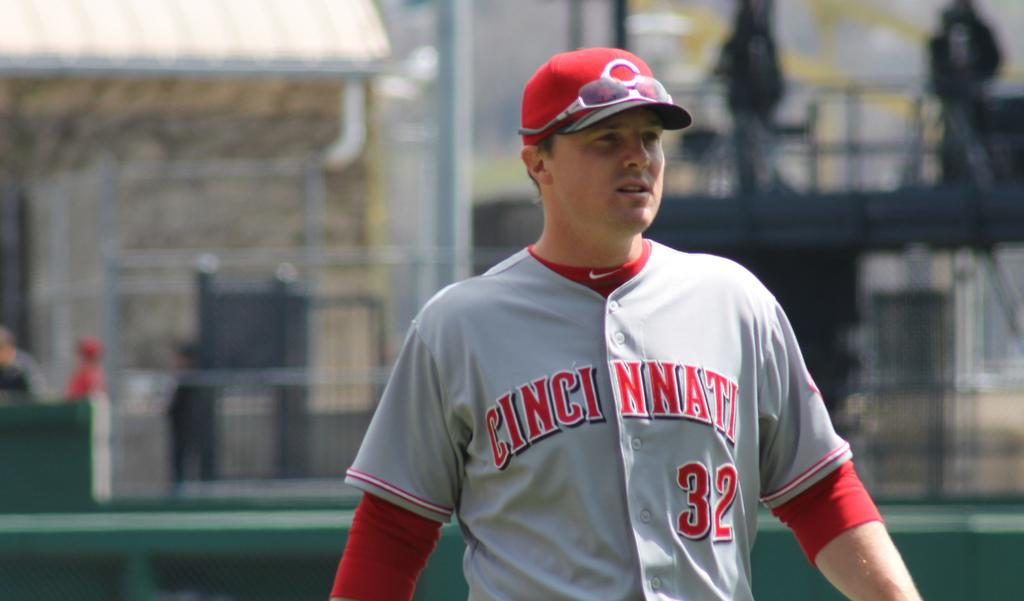<image>
Summarize the visual content of the image. a jersey that has the city of Cincinnati on it 